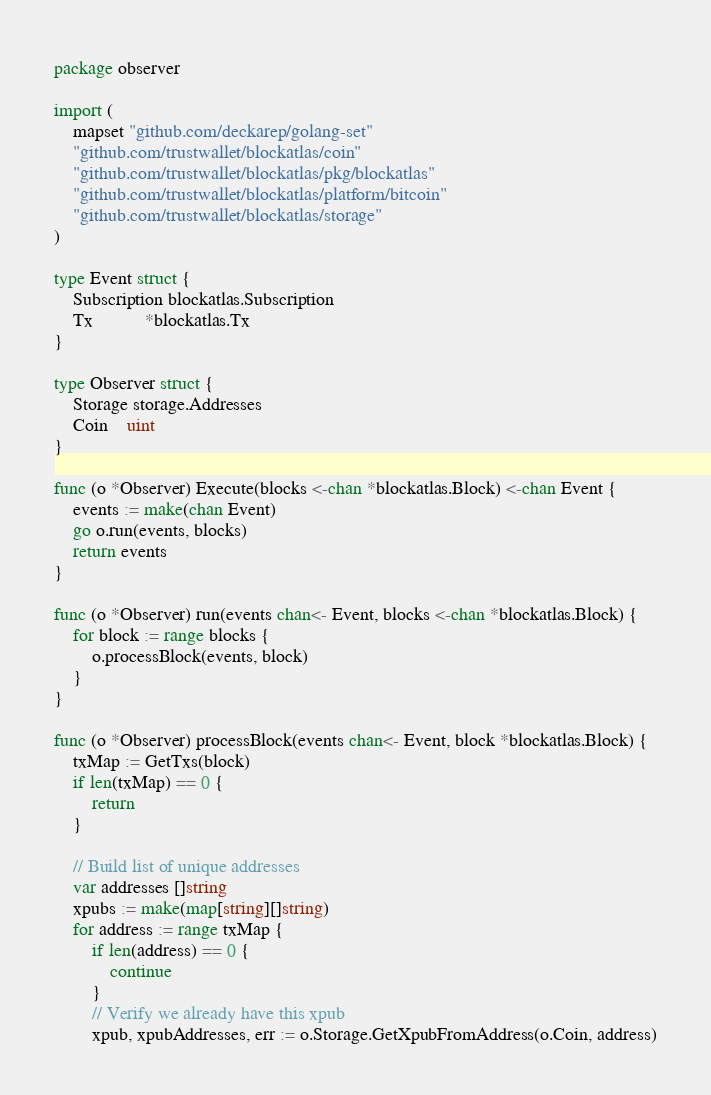<code> <loc_0><loc_0><loc_500><loc_500><_Go_>package observer

import (
	mapset "github.com/deckarep/golang-set"
	"github.com/trustwallet/blockatlas/coin"
	"github.com/trustwallet/blockatlas/pkg/blockatlas"
	"github.com/trustwallet/blockatlas/platform/bitcoin"
	"github.com/trustwallet/blockatlas/storage"
)

type Event struct {
	Subscription blockatlas.Subscription
	Tx           *blockatlas.Tx
}

type Observer struct {
	Storage storage.Addresses
	Coin    uint
}

func (o *Observer) Execute(blocks <-chan *blockatlas.Block) <-chan Event {
	events := make(chan Event)
	go o.run(events, blocks)
	return events
}

func (o *Observer) run(events chan<- Event, blocks <-chan *blockatlas.Block) {
	for block := range blocks {
		o.processBlock(events, block)
	}
}

func (o *Observer) processBlock(events chan<- Event, block *blockatlas.Block) {
	txMap := GetTxs(block)
	if len(txMap) == 0 {
		return
	}

	// Build list of unique addresses
	var addresses []string
	xpubs := make(map[string][]string)
	for address := range txMap {
		if len(address) == 0 {
			continue
		}
		// Verify we already have this xpub
		xpub, xpubAddresses, err := o.Storage.GetXpubFromAddress(o.Coin, address)</code> 